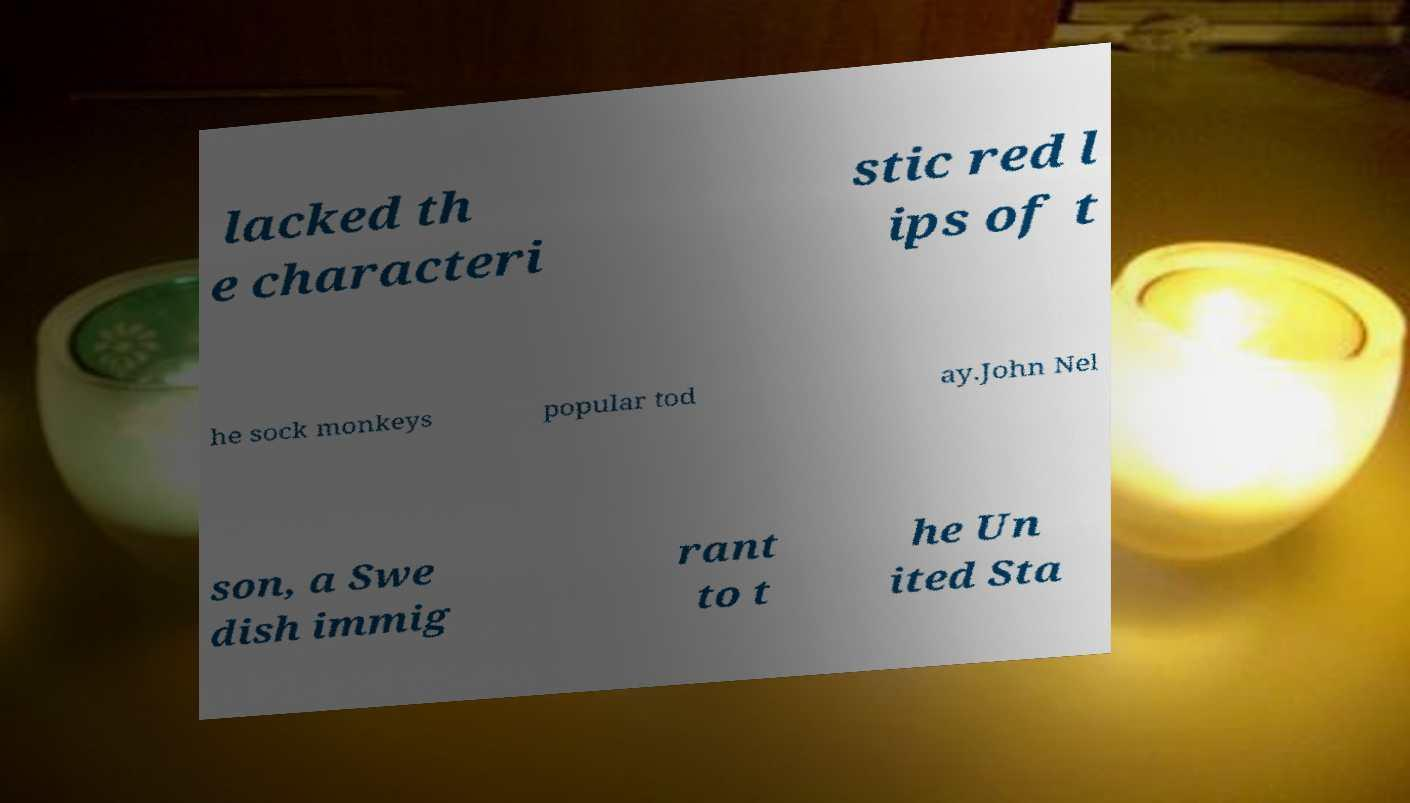Could you extract and type out the text from this image? lacked th e characteri stic red l ips of t he sock monkeys popular tod ay.John Nel son, a Swe dish immig rant to t he Un ited Sta 